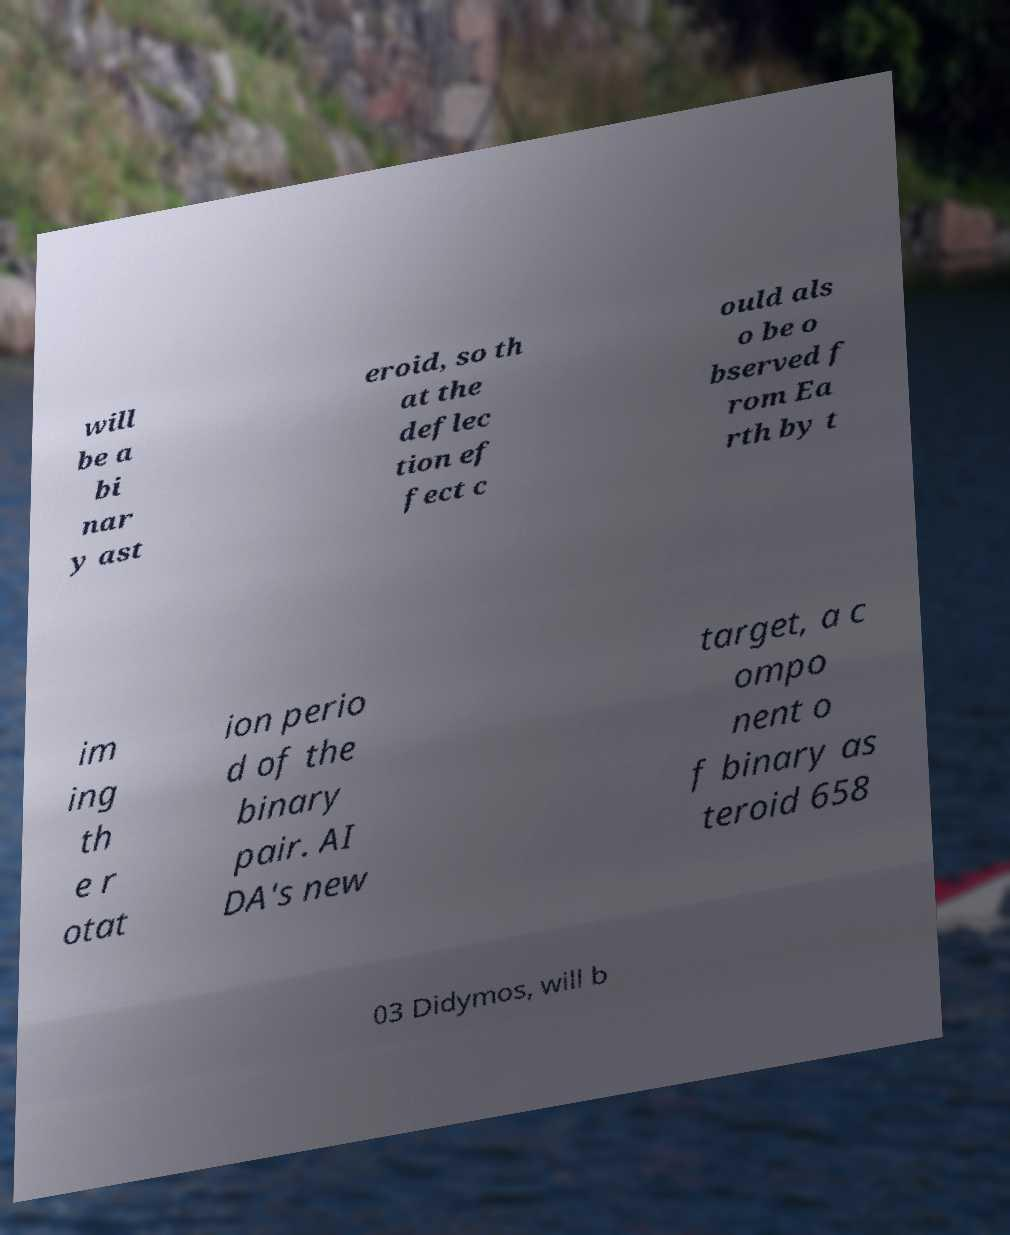I need the written content from this picture converted into text. Can you do that? will be a bi nar y ast eroid, so th at the deflec tion ef fect c ould als o be o bserved f rom Ea rth by t im ing th e r otat ion perio d of the binary pair. AI DA's new target, a c ompo nent o f binary as teroid 658 03 Didymos, will b 